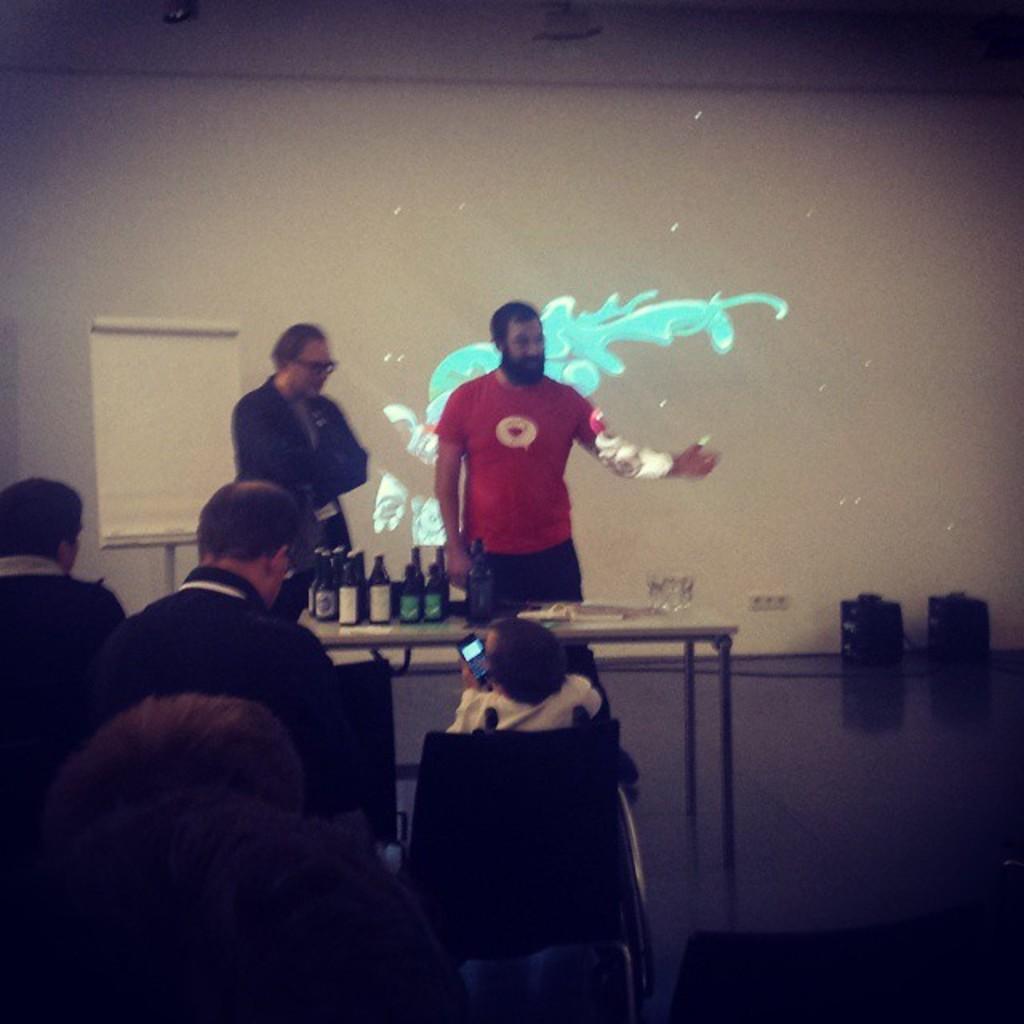Can you describe this image briefly? There are few persons sitting on the chairs. This is a table. On the table there are bottles. There are two persons standing on the floor. In the background we can see a board and a wall. 